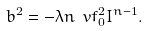Convert formula to latex. <formula><loc_0><loc_0><loc_500><loc_500>b ^ { 2 } = - \lambda n \ v f _ { 0 } ^ { 2 } I ^ { n - 1 } .</formula> 